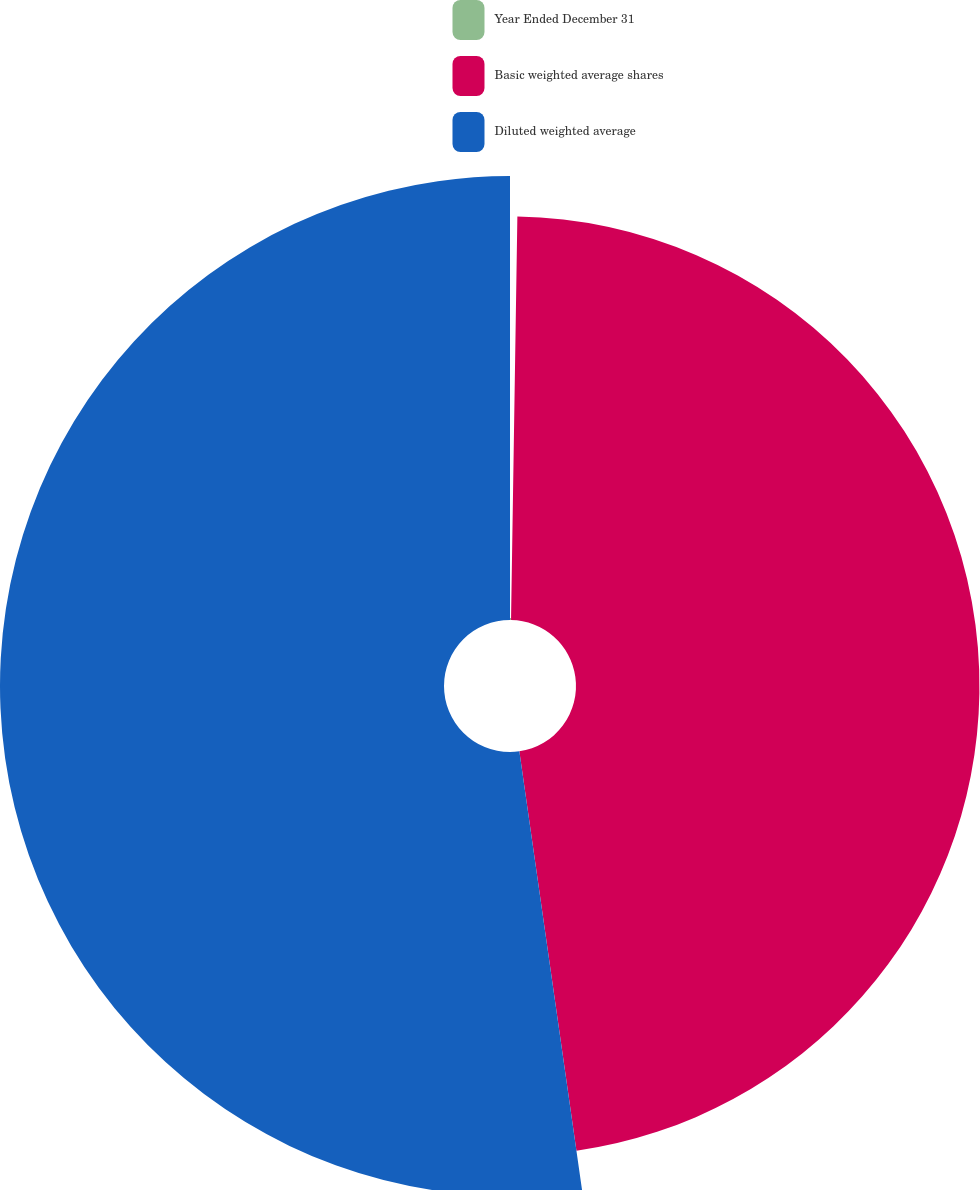Convert chart to OTSL. <chart><loc_0><loc_0><loc_500><loc_500><pie_chart><fcel>Year Ended December 31<fcel>Basic weighted average shares<fcel>Diluted weighted average<nl><fcel>0.25%<fcel>47.49%<fcel>52.26%<nl></chart> 